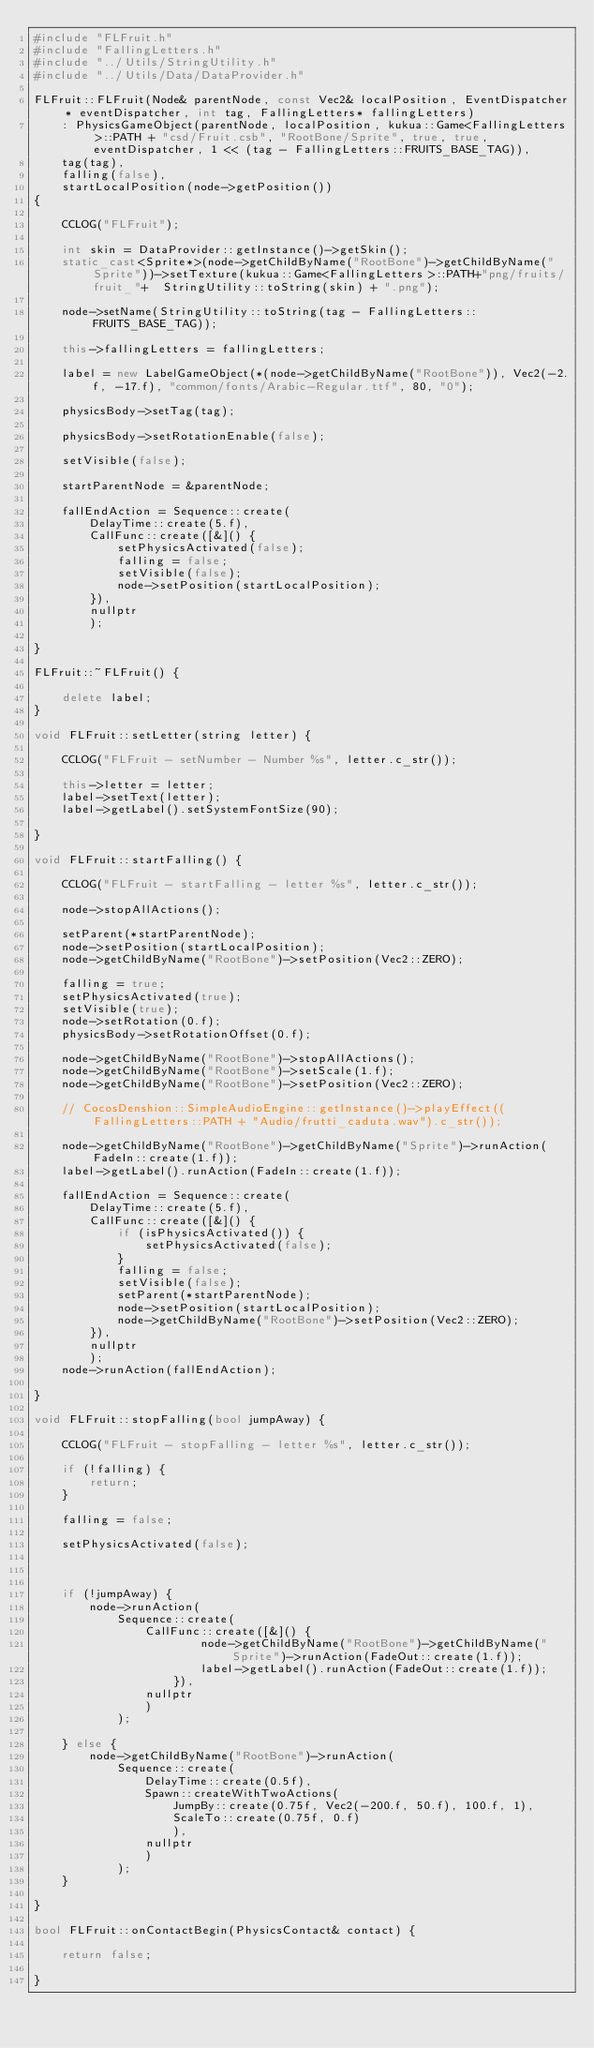<code> <loc_0><loc_0><loc_500><loc_500><_C++_>#include "FLFruit.h"
#include "FallingLetters.h"
#include "../Utils/StringUtility.h"
#include "../Utils/Data/DataProvider.h"

FLFruit::FLFruit(Node& parentNode, const Vec2& localPosition, EventDispatcher* eventDispatcher, int tag, FallingLetters* fallingLetters)
	: PhysicsGameObject(parentNode, localPosition, kukua::Game<FallingLetters>::PATH + "csd/Fruit.csb", "RootBone/Sprite", true, true, eventDispatcher, 1 << (tag - FallingLetters::FRUITS_BASE_TAG)),
	tag(tag),
	falling(false),
	startLocalPosition(node->getPosition())
{

	CCLOG("FLFruit");
    
    int skin = DataProvider::getInstance()->getSkin();
    static_cast<Sprite*>(node->getChildByName("RootBone")->getChildByName("Sprite"))->setTexture(kukua::Game<FallingLetters>::PATH+"png/fruits/fruit_"+  StringUtility::toString(skin) + ".png");

	node->setName(StringUtility::toString(tag - FallingLetters::FRUITS_BASE_TAG));

	this->fallingLetters = fallingLetters;

	label = new LabelGameObject(*(node->getChildByName("RootBone")), Vec2(-2.f, -17.f), "common/fonts/Arabic-Regular.ttf", 80, "0");

	physicsBody->setTag(tag);
    
	physicsBody->setRotationEnable(false);

	setVisible(false);

	startParentNode = &parentNode;

	fallEndAction = Sequence::create(
		DelayTime::create(5.f),
		CallFunc::create([&]() {
			setPhysicsActivated(false);
			falling = false;
			setVisible(false);
			node->setPosition(startLocalPosition);
		}),
		nullptr
		);

}

FLFruit::~FLFruit() {

    delete label;
}

void FLFruit::setLetter(string letter) {

	CCLOG("FLFruit - setNumber - Number %s", letter.c_str());
    
	this->letter = letter;
	label->setText(letter);
	label->getLabel().setSystemFontSize(90);

}

void FLFruit::startFalling() {

	CCLOG("FLFruit - startFalling - letter %s", letter.c_str());

	node->stopAllActions();

	setParent(*startParentNode);
	node->setPosition(startLocalPosition);
	node->getChildByName("RootBone")->setPosition(Vec2::ZERO);

	falling = true;
	setPhysicsActivated(true);
	setVisible(true);
	node->setRotation(0.f);
	physicsBody->setRotationOffset(0.f);

	node->getChildByName("RootBone")->stopAllActions();
	node->getChildByName("RootBone")->setScale(1.f);
	node->getChildByName("RootBone")->setPosition(Vec2::ZERO);

	// CocosDenshion::SimpleAudioEngine::getInstance()->playEffect((FallingLetters::PATH + "Audio/frutti_caduta.wav").c_str());

	node->getChildByName("RootBone")->getChildByName("Sprite")->runAction(FadeIn::create(1.f));
	label->getLabel().runAction(FadeIn::create(1.f));

	fallEndAction = Sequence::create(
		DelayTime::create(5.f),
		CallFunc::create([&]() {
			if (isPhysicsActivated()) {
				setPhysicsActivated(false);
			}
			falling = false;
			setVisible(false);
			setParent(*startParentNode);
			node->setPosition(startLocalPosition);
			node->getChildByName("RootBone")->setPosition(Vec2::ZERO);
		}),
		nullptr
		);
	node->runAction(fallEndAction);

}

void FLFruit::stopFalling(bool jumpAway) {

	CCLOG("FLFruit - stopFalling - letter %s", letter.c_str());

	if (!falling) {
		return;
	}

	falling = false;
	
	setPhysicsActivated(false);



	if (!jumpAway) {
		node->runAction(
			Sequence::create(
				CallFunc::create([&]() {
						node->getChildByName("RootBone")->getChildByName("Sprite")->runAction(FadeOut::create(1.f));
						label->getLabel().runAction(FadeOut::create(1.f));
					}),
				nullptr
				)
			);

	} else {
		node->getChildByName("RootBone")->runAction(
			Sequence::create(
				DelayTime::create(0.5f),
				Spawn::createWithTwoActions(
					JumpBy::create(0.75f, Vec2(-200.f, 50.f), 100.f, 1),
					ScaleTo::create(0.75f, 0.f)
					),
				nullptr
				)
			);
	}

}

bool FLFruit::onContactBegin(PhysicsContact& contact) {

	return false;
	
}
</code> 